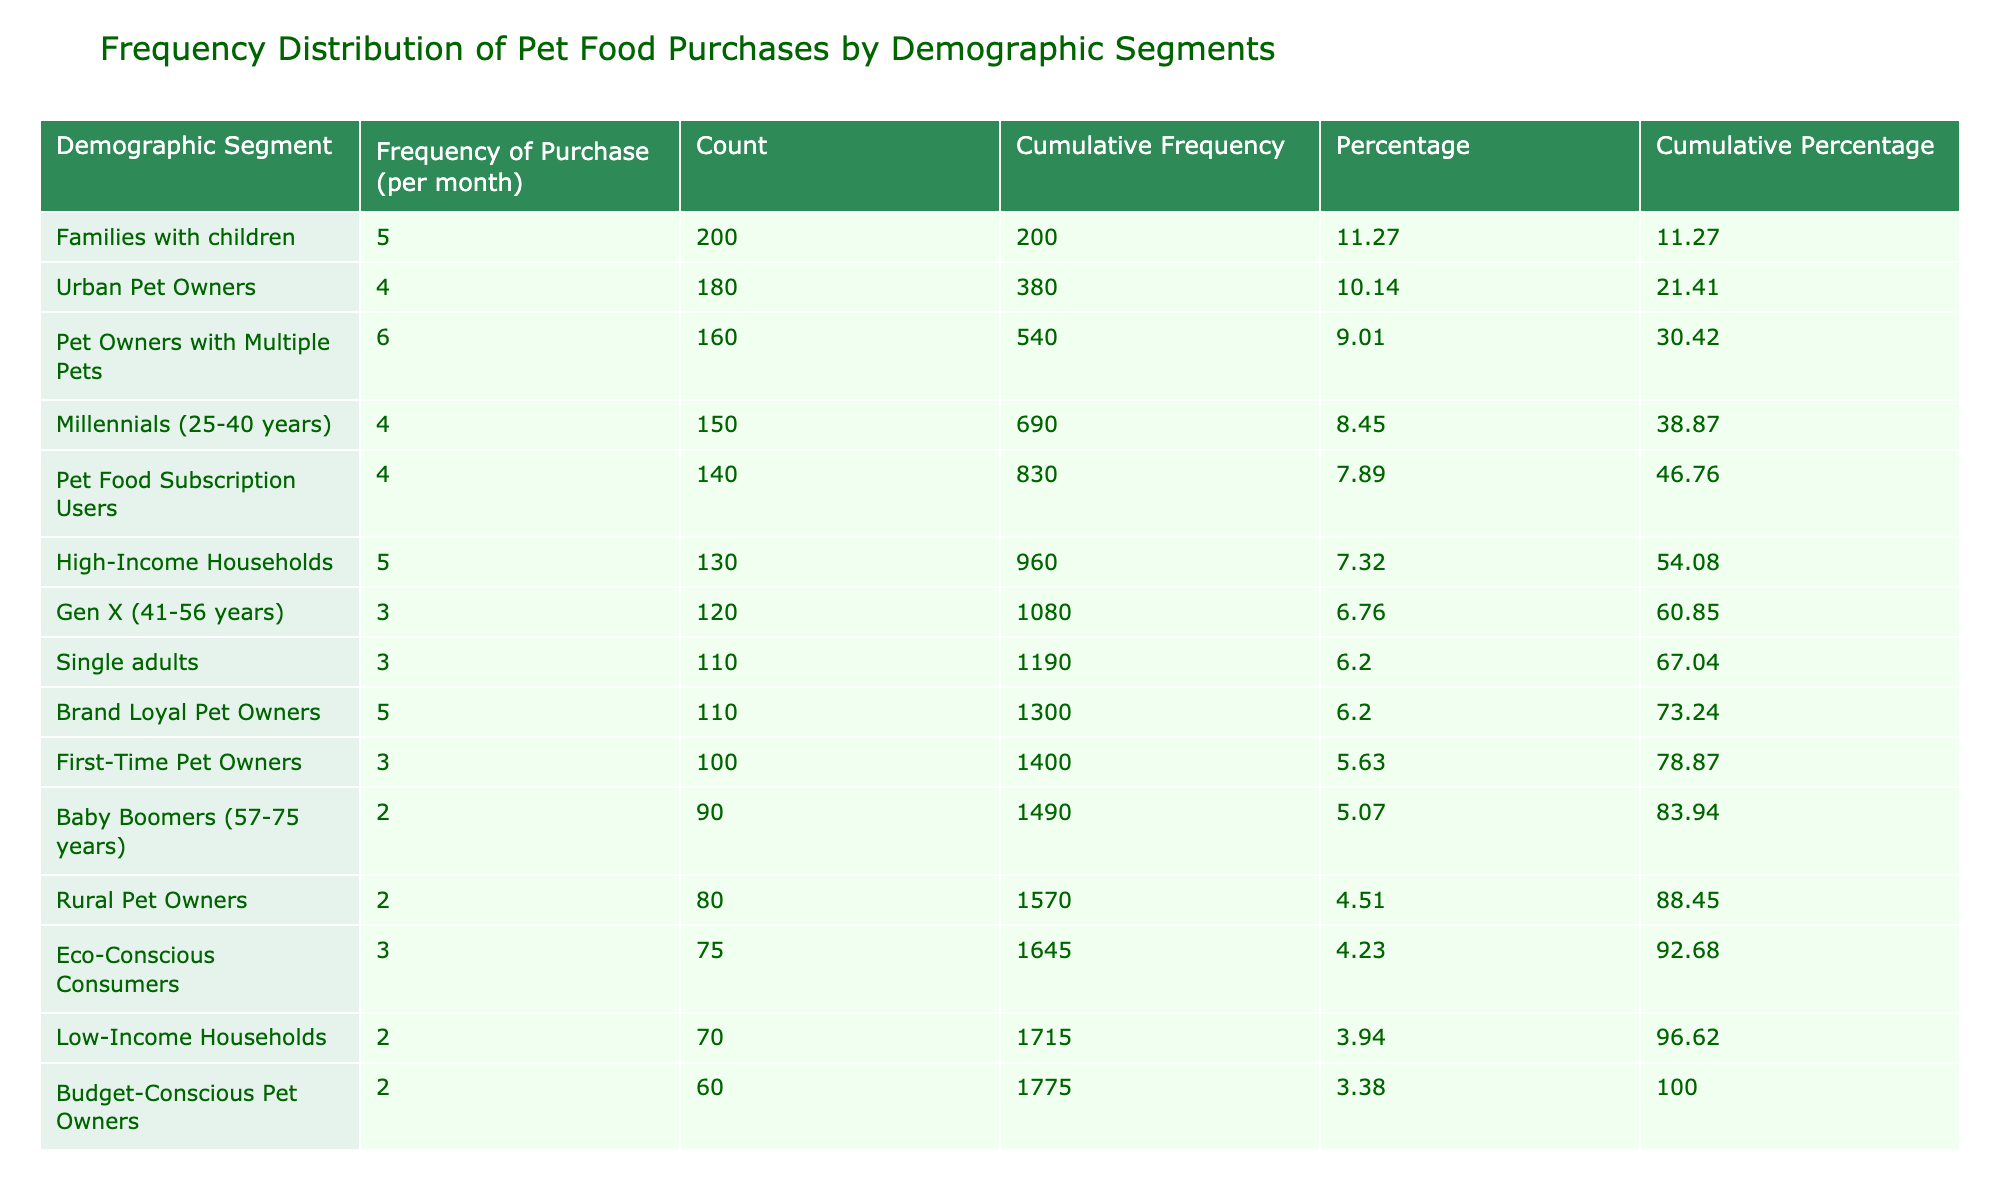What is the frequency of pet food purchases for families with children? The table shows that families with children have a frequency of purchase of 5 per month.
Answer: 5 Which demographic segment has the highest count of pet food purchases? By looking at the count column, families with children have the highest count of 200 purchases.
Answer: 200 How many total pet food purchases are recorded across all demographic segments? To find the total, we sum all the counts: 150 + 120 + 90 + 200 + 110 + 180 + 80 + 130 + 70 + 160 + 100 + 140 + 75 + 110 + 60 =  1,575.
Answer: 1575 What percentage of the total purchases does Pet Owners with Multiple Pets account for? Pet Owners with Multiple Pets have a count of 160. The total count is 1575, so the percentage is (160 / 1575) * 100 = 10.19%.
Answer: 10.19% True or False: Eco-Conscious Consumers have a higher frequency of pet food purchases than Baby Boomers. The frequency for Eco-Conscious Consumers is 3, while Baby Boomers have a frequency of 2. Thus, the statement is True.
Answer: True Which demographic segments have a frequency of purchase of 4 per month? Urban Pet Owners, Millennials, and Pet Food Subscription Users all have a frequency of purchase of 4 per month.
Answer: Urban Pet Owners, Millennials, Pet Food Subscription Users What is the cumulative frequency of purchases for High-Income Households? The count for High-Income Households is 130, and when added to those above it (200 for Families with children, 180 for Urban Pet Owners, and 150 for Millennials), the cumulative frequency becomes 200 + 180 + 150 + 130 = 660.
Answer: 660 What is the average frequency of purchase for all single adults and families with children combined? Single adults have a frequency of 3, and families with children have a frequency of 5. The sum is (3 + 5) = 8, and their average is 8 / 2 = 4.
Answer: 4 Which demographic segment has the lowest frequency of purchase per month? The table indicates that Low-Income Households and Rural Pet Owners both have the lowest frequency of purchase at 2 per month.
Answer: 2 